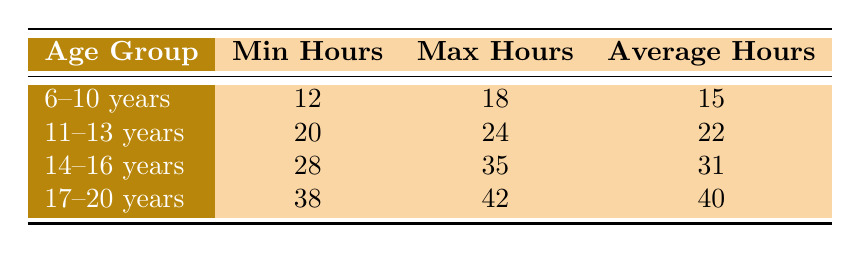What is the average training hours for the 11-13 years age group? The average training hours for the 11-13 years age group is provided directly in the table, which states it is 22 hours.
Answer: 22 What is the minimum training hours for the 14-16 years age group? The table shows that the minimum training hours for the 14-16 years age group is 28 hours.
Answer: 28 Is the maximum training hours for the 6-10 years age group greater than 20? By looking at the table, the maximum training hours for the 6-10 years age group is 18; therefore, it is not greater than 20.
Answer: No What is the difference in average hours between the 17-20 years age group and the 14-16 years age group? The average for the 17-20 years age group is 40 hours, and for the 14-16 years age group it is 31 hours. The difference is 40 - 31 = 9 hours.
Answer: 9 Which age group has the highest maximum training hours? The table indicates that the 17-20 years age group has the maximum training hours of 42, which is higher than the maximum hours of other age groups.
Answer: 17-20 years What is the total of minimum training hours for all age groups? The minimum hours for each age group are: 12 (6-10 years), 20 (11-13 years), 28 (14-16 years), and 38 (17-20 years). Summing these gives 12 + 20 + 28 + 38 = 98 hours.
Answer: 98 How many age groups have an average training hour of more than 30? The only age group with an average greater than 30 is the 14-16 years age group (31 hours) and the 17-20 years age group (40 hours). Therefore, there are two age groups.
Answer: 2 What is the range of training hours in the 6-10 years age group? The range is calculated by subtracting the minimum hours (12) from the maximum hours (18), resulting in a range of 18 - 12 = 6 hours.
Answer: 6 Which age group has the lowest average training hours? The lowest average hours are for the 6-10 years age group, which has an average of 15 hours according to the table.
Answer: 6-10 years 